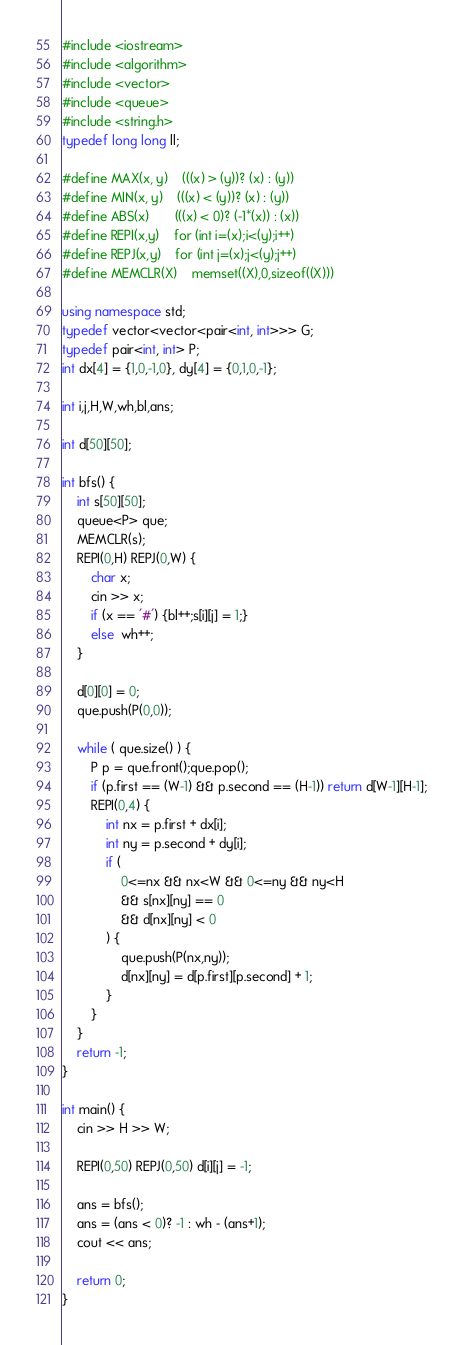<code> <loc_0><loc_0><loc_500><loc_500><_C++_>#include <iostream>
#include <algorithm>
#include <vector>
#include <queue>
#include <string.h>
typedef long long ll;

#define MAX(x, y)	(((x) > (y))? (x) : (y))
#define MIN(x, y)	(((x) < (y))? (x) : (y))
#define ABS(x)		(((x) < 0)? (-1*(x)) : (x))
#define REPI(x,y)	for (int i=(x);i<(y);i++)
#define REPJ(x,y)	for (int j=(x);j<(y);j++)
#define MEMCLR(X)	memset((X),0,sizeof((X)))

using namespace std;
typedef vector<vector<pair<int, int>>> G;
typedef pair<int, int> P;
int dx[4] = {1,0,-1,0}, dy[4] = {0,1,0,-1};

int i,j,H,W,wh,bl,ans;

int d[50][50];

int bfs() {
	int s[50][50];
	queue<P> que;
	MEMCLR(s);
	REPI(0,H) REPJ(0,W) {
		char x;
		cin >> x;
		if (x == '#') {bl++;s[i][j] = 1;}
		else  wh++;
	}

	d[0][0] = 0;
	que.push(P(0,0));
	
	while ( que.size() ) {
		P p = que.front();que.pop();
		if (p.first == (W-1) && p.second == (H-1)) return d[W-1][H-1];
		REPI(0,4) {
			int nx = p.first + dx[i];
			int ny = p.second + dy[i];
			if (
				0<=nx && nx<W && 0<=ny && ny<H
				&& s[nx][ny] == 0
				&& d[nx][ny] < 0
			) {
				que.push(P(nx,ny));
				d[nx][ny] = d[p.first][p.second] + 1;
			}
		}
	}
	return -1;
}

int main() {
	cin >> H >> W;
	
	REPI(0,50) REPJ(0,50) d[i][j] = -1;
	
	ans = bfs();
	ans = (ans < 0)? -1 : wh - (ans+1);
	cout << ans;
	
	return 0;
}
</code> 